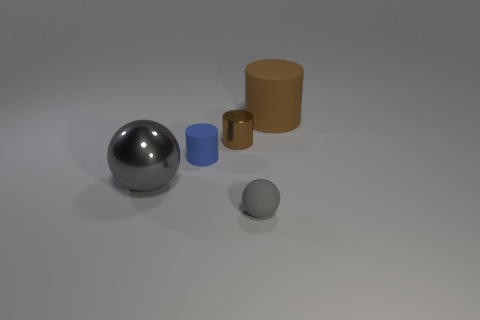There is a large object that is the same color as the small sphere; what is its material?
Offer a very short reply. Metal. Do the small brown cylinder and the gray ball that is right of the shiny cylinder have the same material?
Give a very brief answer. No. How many brown objects are large things or small metallic balls?
Offer a very short reply. 1. Are any tiny brown shiny cubes visible?
Provide a succinct answer. No. Are there any cylinders left of the blue cylinder in front of the cylinder on the right side of the small gray ball?
Keep it short and to the point. No. Is there any other thing that is the same size as the gray metal object?
Offer a very short reply. Yes. Do the big brown object and the gray thing that is to the left of the small blue cylinder have the same shape?
Make the answer very short. No. There is a big object right of the gray thing in front of the sphere that is behind the gray rubber ball; what is its color?
Offer a terse response. Brown. What number of things are either rubber cylinders that are in front of the big brown thing or things that are to the right of the small matte sphere?
Keep it short and to the point. 2. How many other objects are the same color as the big metal object?
Your response must be concise. 1. 